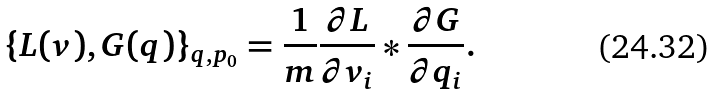<formula> <loc_0><loc_0><loc_500><loc_500>\{ L ( { v } ) , G ( { q } ) \} _ { { q } , { p } _ { 0 } } = \frac { 1 } { m } \frac { \partial L } { \partial v _ { i } } * \frac { \partial G } { \partial q _ { i } } .</formula> 